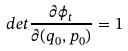Convert formula to latex. <formula><loc_0><loc_0><loc_500><loc_500>d e t \frac { \partial \phi _ { t } } { \partial ( q _ { 0 } , p _ { 0 } ) } = 1</formula> 